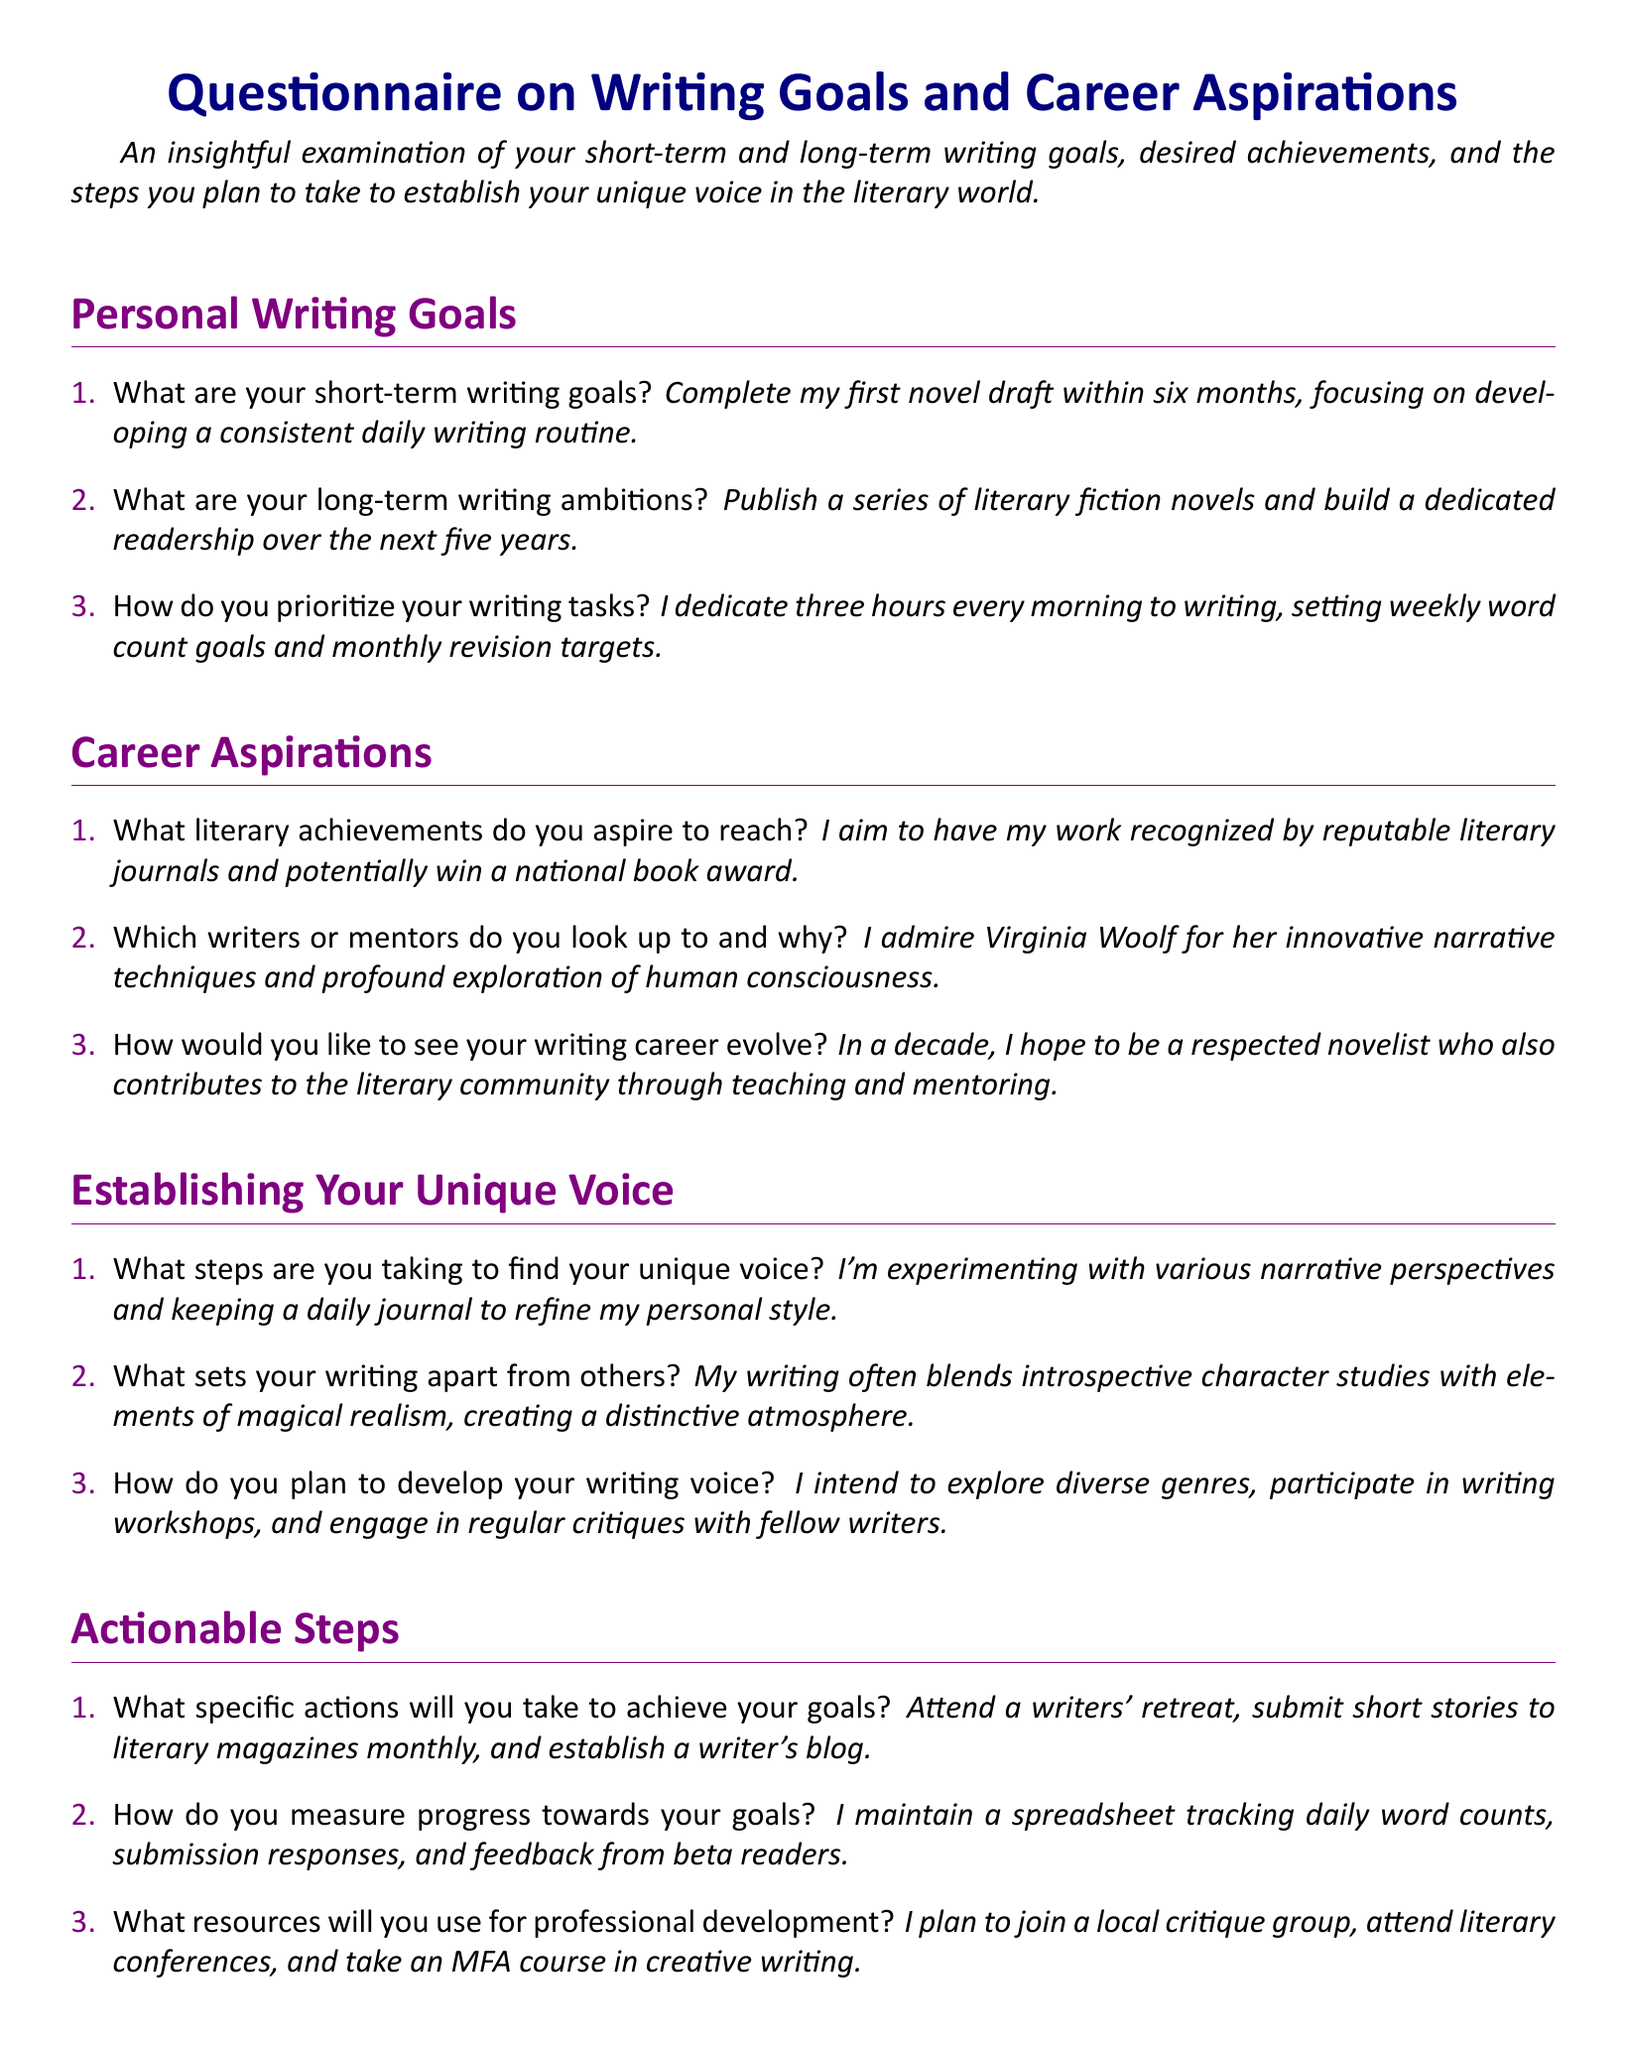What are your short-term writing goals? This question asks for the specific short-term writing goals stated in the document.
Answer: Complete my first novel draft within six months, focusing on developing a consistent daily writing routine What steps are you taking to find your unique voice? This question looks for the actions detailed in the document aimed at discovering a unique writing style.
Answer: I'm experimenting with various narrative perspectives and keeping a daily journal to refine my personal style How do you measure progress towards your goals? This question seeks to identify the method used to track writing progress mentioned in the document.
Answer: I maintain a spreadsheet tracking daily word counts, submission responses, and feedback from beta readers What literary achievements do you aspire to reach? This question requests the specific literary accomplishments the writer hopes to obtain as outlined in the document.
Answer: I aim to have my work recognized by reputable literary journals and potentially win a national book award Which writers or mentors do you look up to and why? This question focuses on identifying the writers the respondent admires as stated in the document.
Answer: I admire Virginia Woolf for her innovative narrative techniques and profound exploration of human consciousness What specific actions will you take to achieve your goals? This question seeks the actions listed in the document that the writer plans to implement for achieving their goals.
Answer: Attend a writers' retreat, submit short stories to literary magazines monthly, and establish a writer's blog 